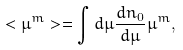<formula> <loc_0><loc_0><loc_500><loc_500>< \mu ^ { m } > = \int d \mu \frac { d n _ { 0 } } { d \mu } \mu ^ { m } ,</formula> 